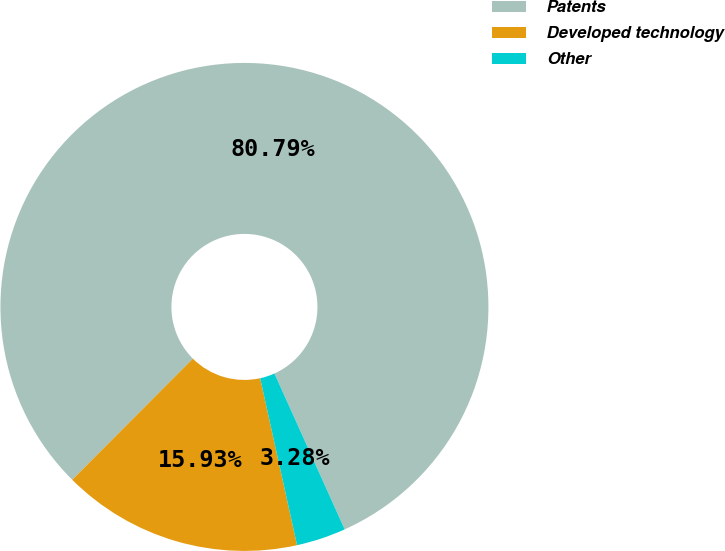Convert chart. <chart><loc_0><loc_0><loc_500><loc_500><pie_chart><fcel>Patents<fcel>Developed technology<fcel>Other<nl><fcel>80.78%<fcel>15.93%<fcel>3.28%<nl></chart> 